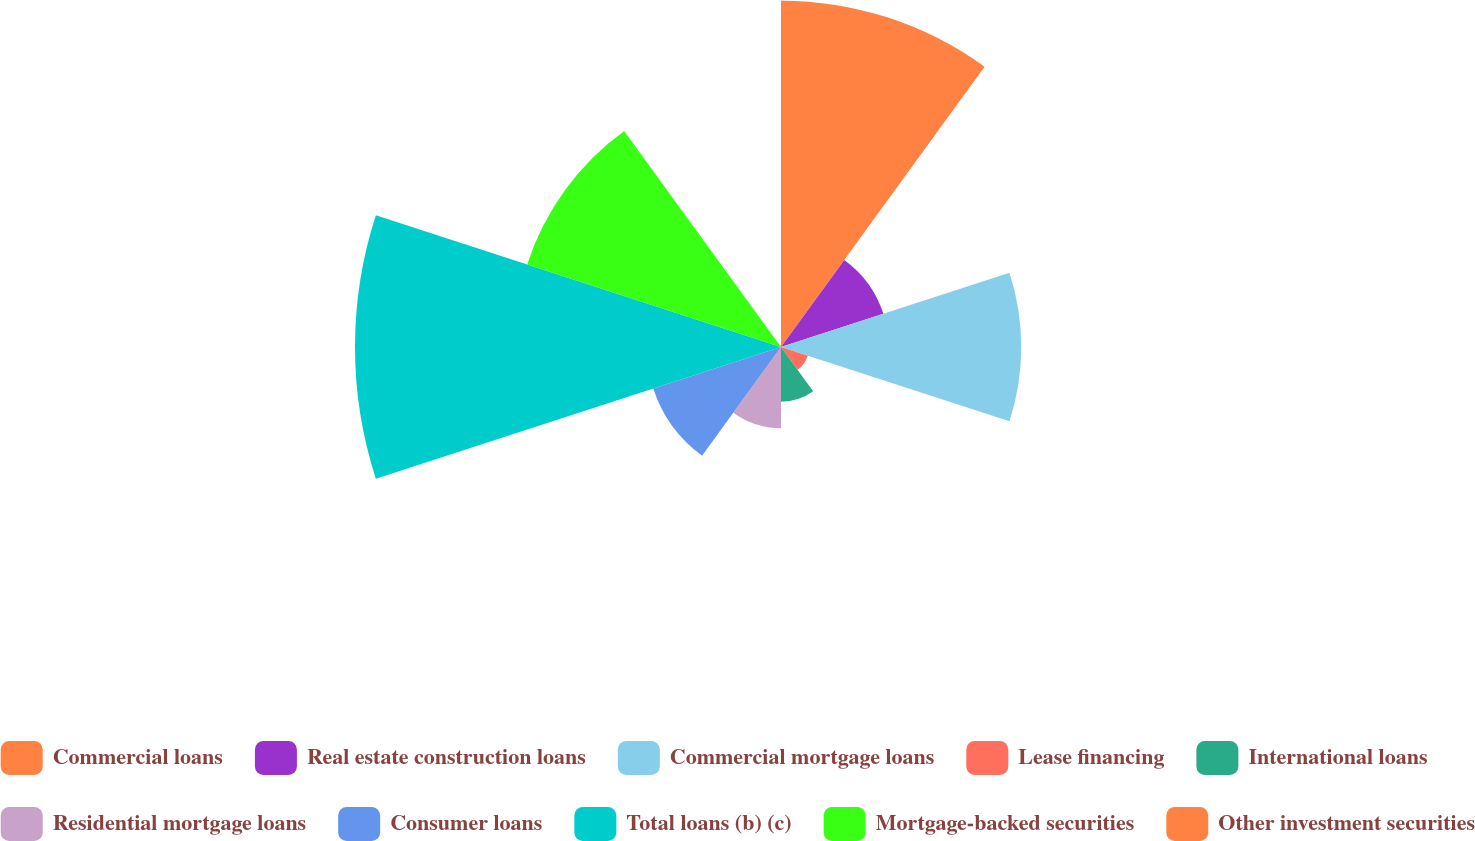Convert chart to OTSL. <chart><loc_0><loc_0><loc_500><loc_500><pie_chart><fcel>Commercial loans<fcel>Real estate construction loans<fcel>Commercial mortgage loans<fcel>Lease financing<fcel>International loans<fcel>Residential mortgage loans<fcel>Consumer loans<fcel>Total loans (b) (c)<fcel>Mortgage-backed securities<fcel>Other investment securities<nl><fcel>20.53%<fcel>6.38%<fcel>14.24%<fcel>1.67%<fcel>3.24%<fcel>4.81%<fcel>7.96%<fcel>25.25%<fcel>15.82%<fcel>0.1%<nl></chart> 